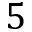<formula> <loc_0><loc_0><loc_500><loc_500>5</formula> 